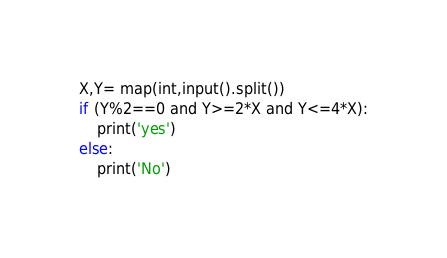<code> <loc_0><loc_0><loc_500><loc_500><_Python_>X,Y= map(int,input().split())
if (Y%2==0 and Y>=2*X and Y<=4*X):
    print('yes')
else:
    print('No')
</code> 